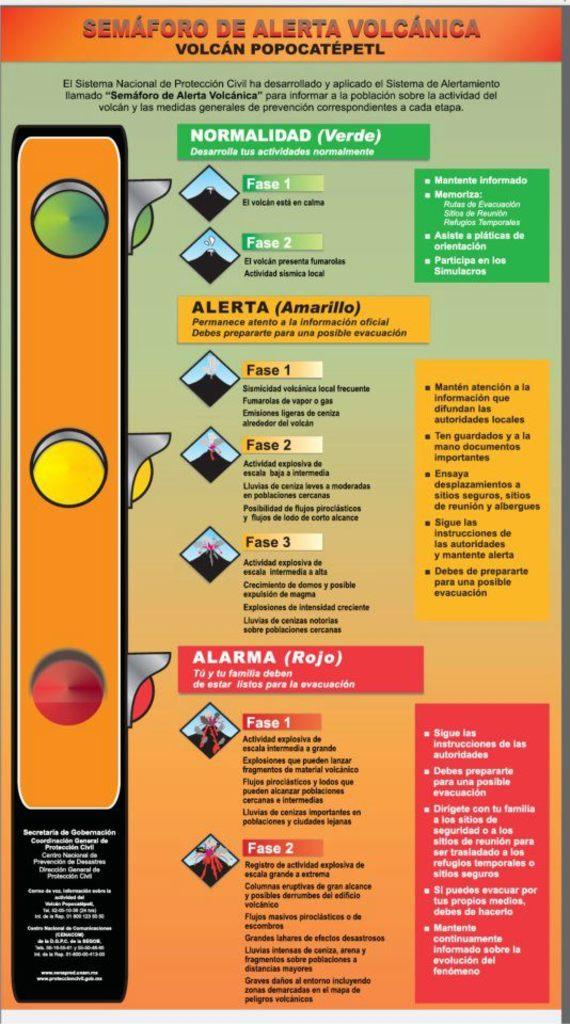<image>
Give a short and clear explanation of the subsequent image. A poster with traffic signals showing reviews when to be comfortable, alerted or alarmed based on different events. 